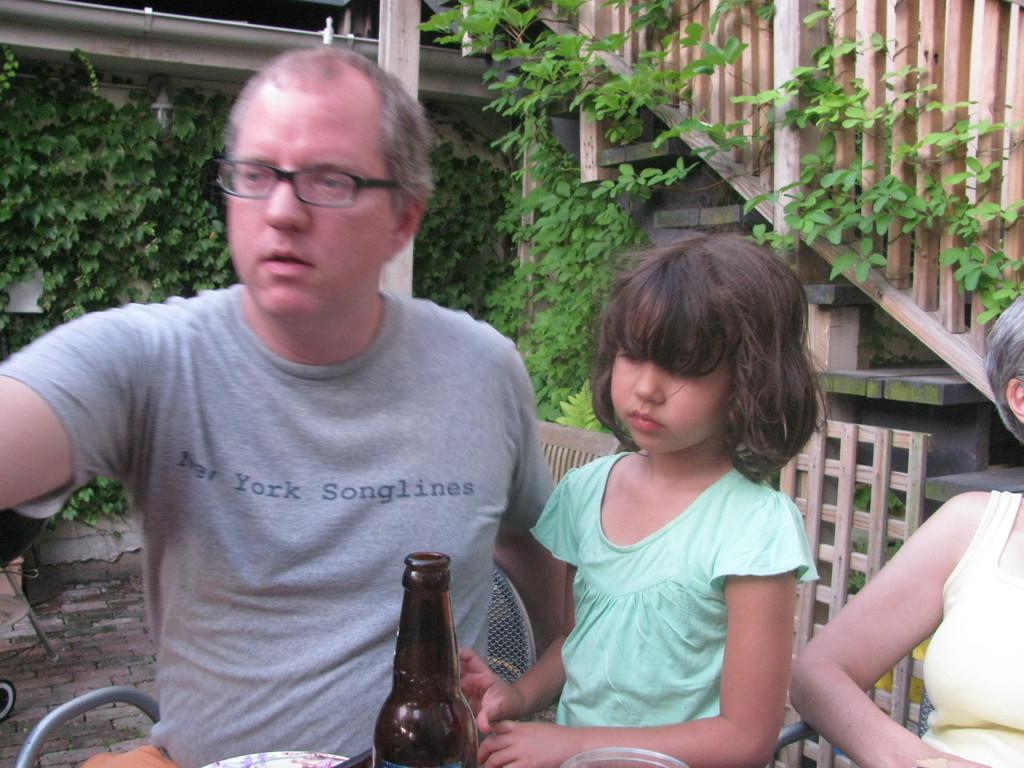How many people are sitting on chairs in the image? There are three people sitting on chairs in the image: a man, a girl, and a woman. What is the object made of glass in the image? There is a glass bottle in the image. What type of vegetation can be seen in the image? There are plants in the image. What architectural feature is present in the image? There are stairs in the image. What type of lumber is being used to construct the chairs in the image? The chairs in the image are not made of lumber; they are made of a different material, such as wood or metal. What type of cherry is being served in the image? There is no cherry present in the image. 